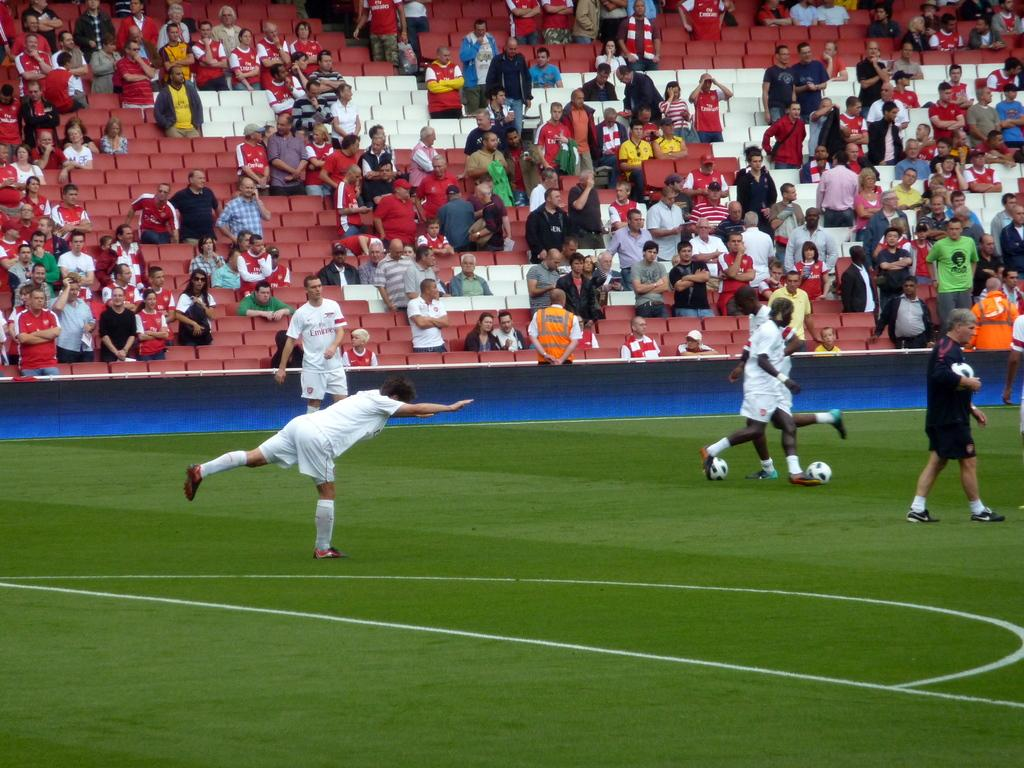<image>
Give a short and clear explanation of the subsequent image. soccer players in a field wearing Emirates jerseys 